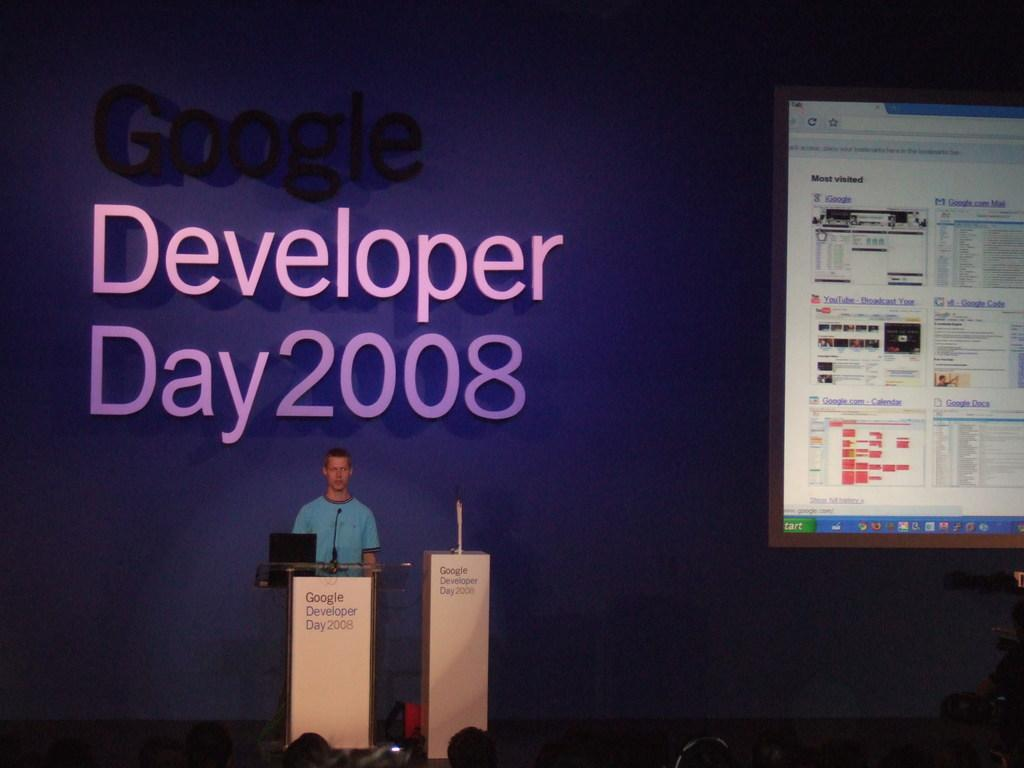<image>
Create a compact narrative representing the image presented. Man giving a presentation in front of a purple walla that says Google Developer Day 2008. 